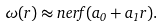Convert formula to latex. <formula><loc_0><loc_0><loc_500><loc_500>\omega ( r ) \approx n e r f ( a _ { 0 } + a _ { 1 } r ) .</formula> 